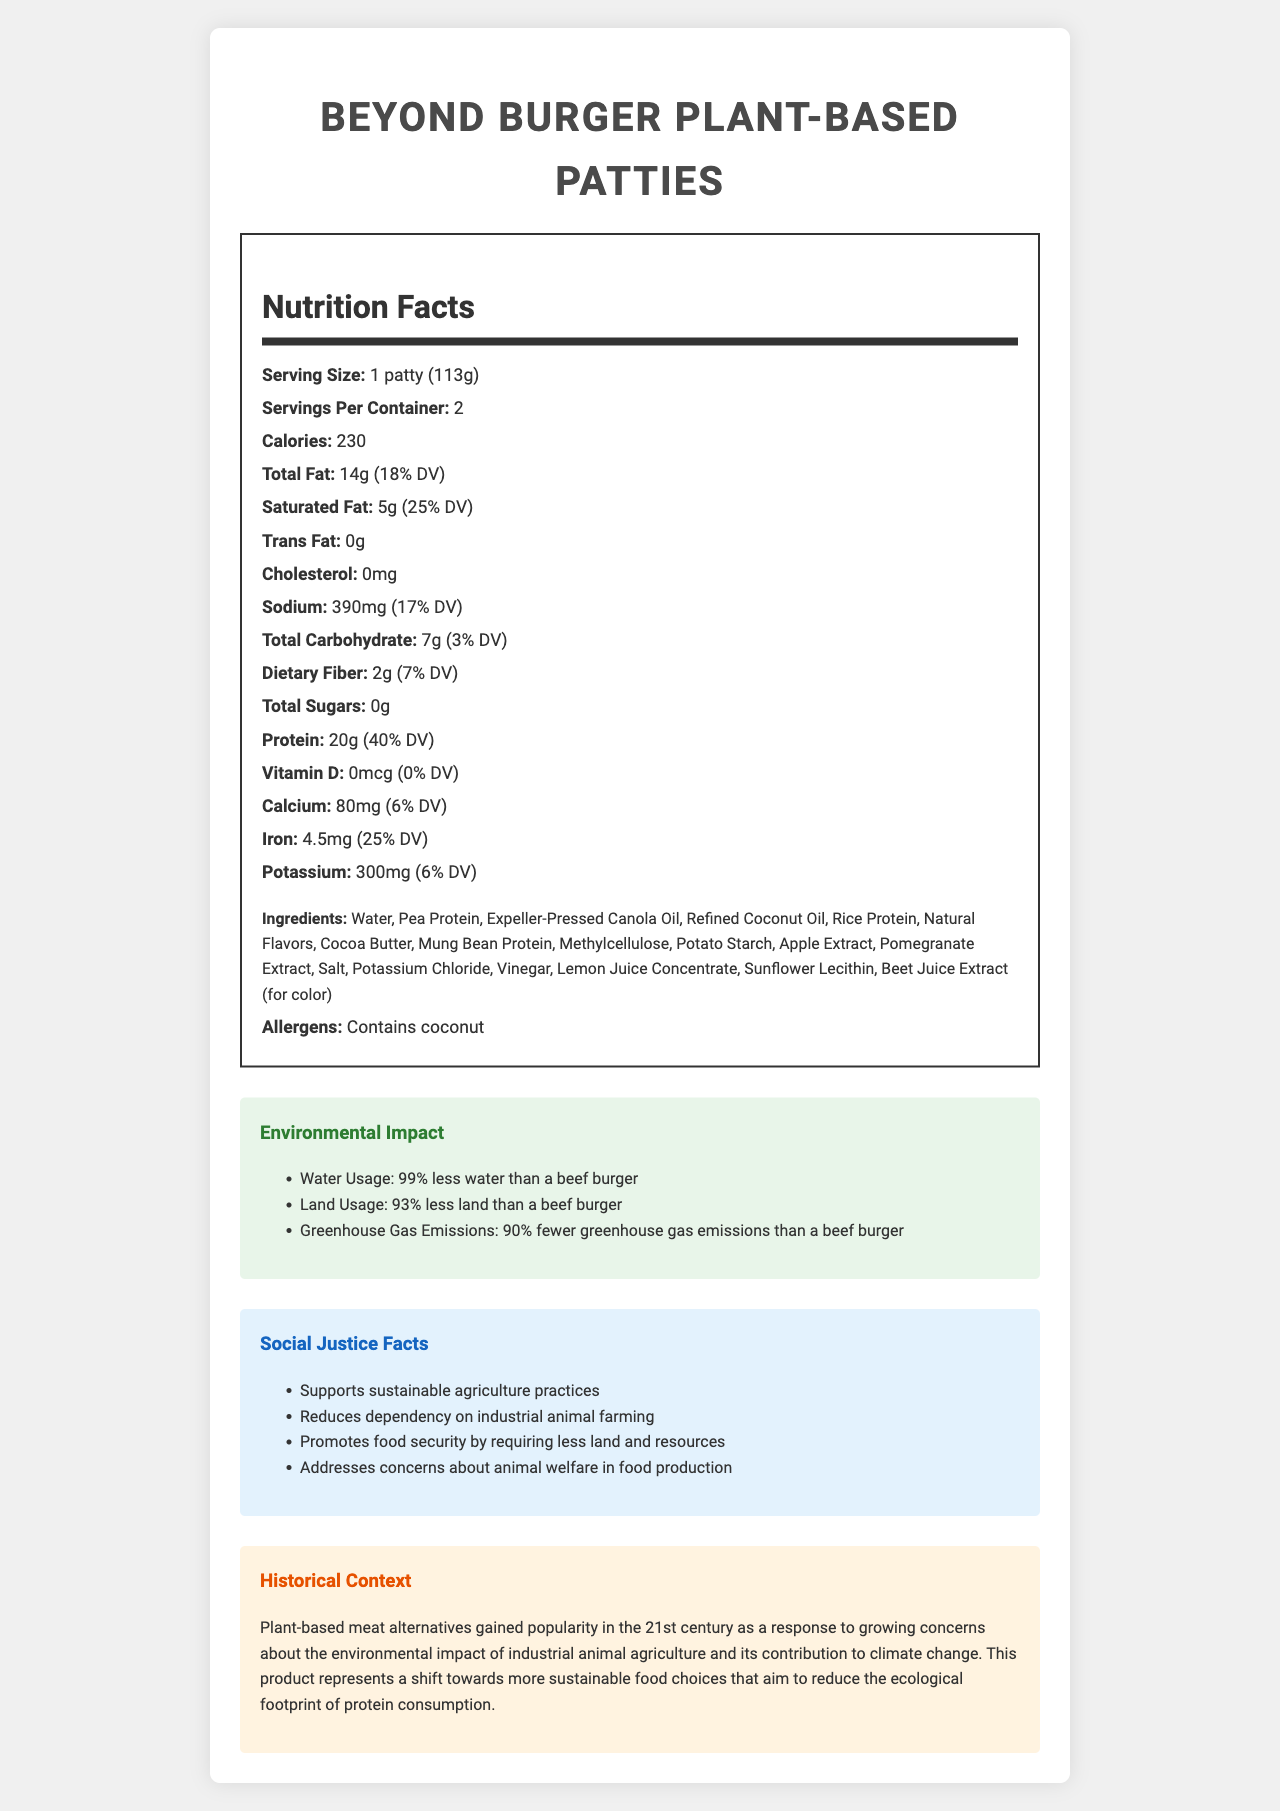what is the protein content per serving? The nutrition label specifies that the protein content per serving of the Beyond Burger Plant-Based Patties is 20 grams.
Answer: 20g what percentage of daily value does the iron content represent? According to the nutrition label, the iron content in one serving is 4.5 mg, which represents 25% of the daily value.
Answer: 25% how does the sodium content per serving compare to the daily value? The nutrition label states that the sodium content per serving is 390 mg, which is 17% of the daily value.
Answer: 390mg (17% DV) list the main ingredients in the Beyond Burger Plant-Based Patties. These ingredients are listed prominently at the beginning of the ingredients list on the label.
Answer: Water, Pea Protein, Expeller-Pressed Canola Oil, Refined Coconut Oil, Rice Protein does the product contain any allergens? The product contains coconut, which is listed under allergens.
Answer: Yes What certifications does the product have? A. Organic B. Non-GMO Project Verified C. Kosher D. Halal The product is Non-GMO Project Verified, Kosher, and Halal, but not certified organic.
Answer: B, C, D How much less water does this product use compared to a beef burger? A. 75% B. 90% C. 99% D. 100% The environmental impact section states that the product uses 99% less water than a beef burger.
Answer: C is the Beyond Burger Plant-Based Patty suitable for a vegan diet? The ingredients and lack of animal-derived components indicate it is suitable for a vegan diet.
Answer: Yes summarize the nutritional benefits and environmental impact of Beyond Burger Plant-Based Patties. The nutrition label and environmental impact section highlight the nutritional benefits such as high protein content and low cholesterol, while emphasizing the substantial reductions in environmental resource usage and emissions.
Answer: The Beyond Burger Plant-Based Patties offer significant protein content (20g per serving) with reduced fat and no cholesterol. Environmentally, it uses 99% less water, 93% less land, and produces 90% fewer greenhouse gas emissions compared to a beef burger. how much greenhouse gas emissions are reduced by consuming this product compared to a beef burger? The environmental impact section indicates that the product produces 90% fewer greenhouse gas emissions than a beef burger.
Answer: 90% can you determine the price of the Beyond Burger Plant-Based Patties from the document? The document does not include any pricing information for the product.
Answer: Not enough information how many servings are in one container? The nutrition label lists that there are 2 servings per container.
Answer: 2 what is the historical context of plant-based meat alternatives mentioned in the document? The historical context section details the rise of plant-based meat alternatives as a response to environmental and climate concerns.
Answer: Plant-based meat alternatives gained popularity in the 21st century due to concerns about the environmental impact of industrial animal agriculture and its contribution to climate change. how much saturated fat does one serving contain? The nutrition label indicates that each serving contains 5 grams of saturated fat, which represents 25% of the daily value.
Answer: 5g 